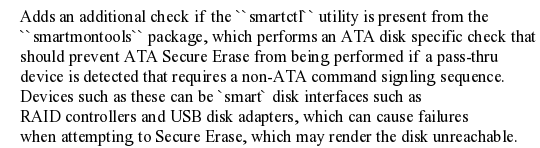Convert code to text. <code><loc_0><loc_0><loc_500><loc_500><_YAML_>    Adds an additional check if the ``smartctl`` utility is present from the
    ``smartmontools`` package, which performs an ATA disk specific check that
    should prevent ATA Secure Erase from being performed if a pass-thru
    device is detected that requires a non-ATA command signling sequence.
    Devices such as these can be `smart` disk interfaces such as
    RAID controllers and USB disk adapters, which can cause failures
    when attempting to Secure Erase, which may render the disk unreachable.
</code> 